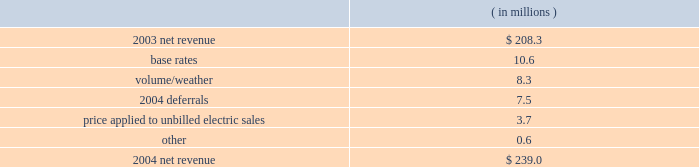Entergy new orleans , inc .
Management's financial discussion and analysis results of operations net income ( loss ) 2004 compared to 2003 net income increased $ 20.2 million primarily due to higher net revenue .
2003 compared to 2002 entergy new orleans had net income of $ 7.9 million in 2003 compared to a net loss in 2002 .
The increase was due to higher net revenue and lower interest expense , partially offset by higher other operation and maintenance expenses and depreciation and amortization expenses .
Net revenue 2004 compared to 2003 net revenue , which is entergy new orleans' measure of gross margin , consists of operating revenues net of : 1 ) fuel , fuel-related , and purchased power expenses and 2 ) other regulatory credits .
Following is an analysis of the change in net revenue comparing 2004 to 2003. .
The increase in base rates was effective june 2003 .
The rate increase is discussed in note 2 to the domestic utility companies and system energy financial statements .
The volume/weather variance is primarily due to increased billed electric usage of 162 gwh in the industrial service sector .
The increase was partially offset by milder weather in the residential and commercial sectors .
The 2004 deferrals variance is due to the deferral of voluntary severance plan and fossil plant maintenance expenses in accordance with a stipulation approved by the city council in august 2004 .
The stipulation allows for the recovery of these costs through amortization of a regulatory asset .
The voluntary severance plan and fossil plant maintenance expenses are being amortized over a five-year period that became effective january 2004 and january 2003 , respectively .
The formula rate plan is discussed in note 2 to the domestic utility companies and system energy financial statements .
The price applied to unbilled electric sales variance is due to an increase in the fuel price applied to unbilled sales. .
What portion of the net change in net revenue during 2004 occurred due to the volume/weather? 
Computations: (8.3 / (239.0 - 208.3))
Answer: 0.27036. 